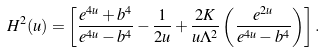Convert formula to latex. <formula><loc_0><loc_0><loc_500><loc_500>H ^ { 2 } ( u ) = \left [ \frac { e ^ { 4 u } + b ^ { 4 } } { e ^ { 4 u } - b ^ { 4 } } - \frac { 1 } { 2 u } + \frac { 2 K } { u \Lambda ^ { 2 } } \left ( \frac { e ^ { 2 u } } { e ^ { 4 u } - b ^ { 4 } } \right ) \right ] .</formula> 